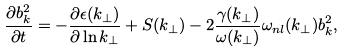Convert formula to latex. <formula><loc_0><loc_0><loc_500><loc_500>\frac { \partial b _ { k } ^ { 2 } } { \partial t } = - \frac { \partial \epsilon ( k _ { \perp } ) } { \partial \ln k _ { \perp } } + S ( k _ { \perp } ) - 2 \frac { \gamma ( k _ { \perp } ) } { \omega ( k _ { \perp } ) } \omega _ { n l } ( k _ { \perp } ) b _ { k } ^ { 2 } ,</formula> 